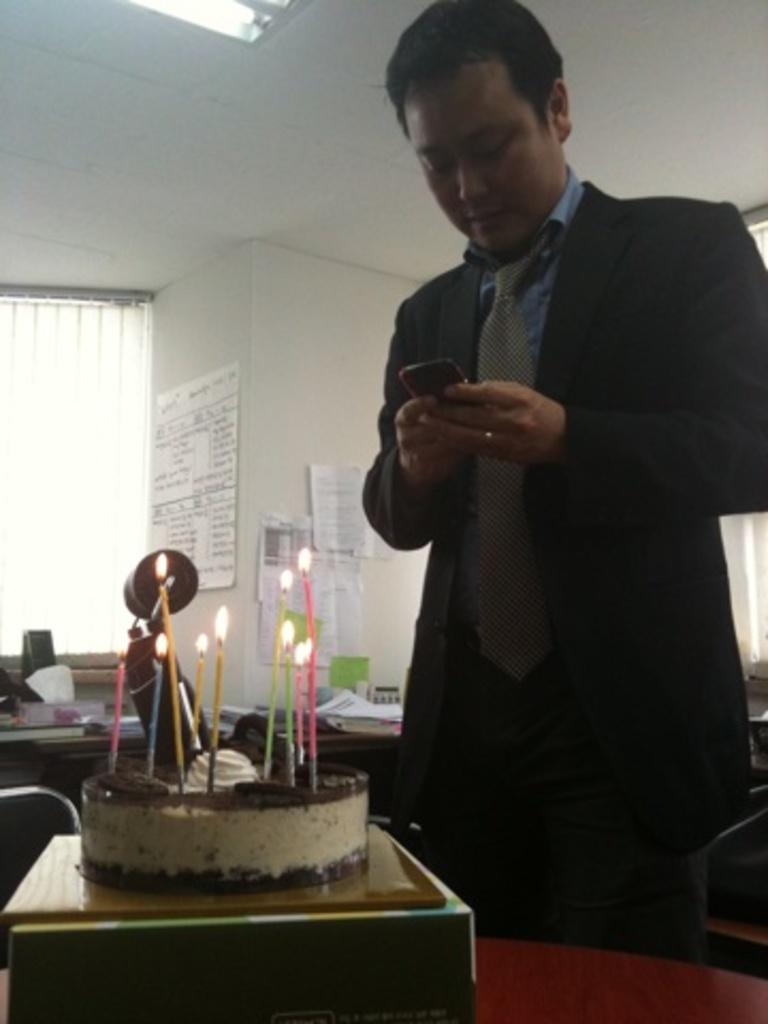How would you summarize this image in a sentence or two? In the background we can see window blind. We can see papers with some information. Papers are pasted on the walls. At the top we can see the ceiling and light. In this picture we can see a man is holding a mobile and he is staring at a mobile. On the tables we can see papers, tissue box, cake, candles and few objects. 